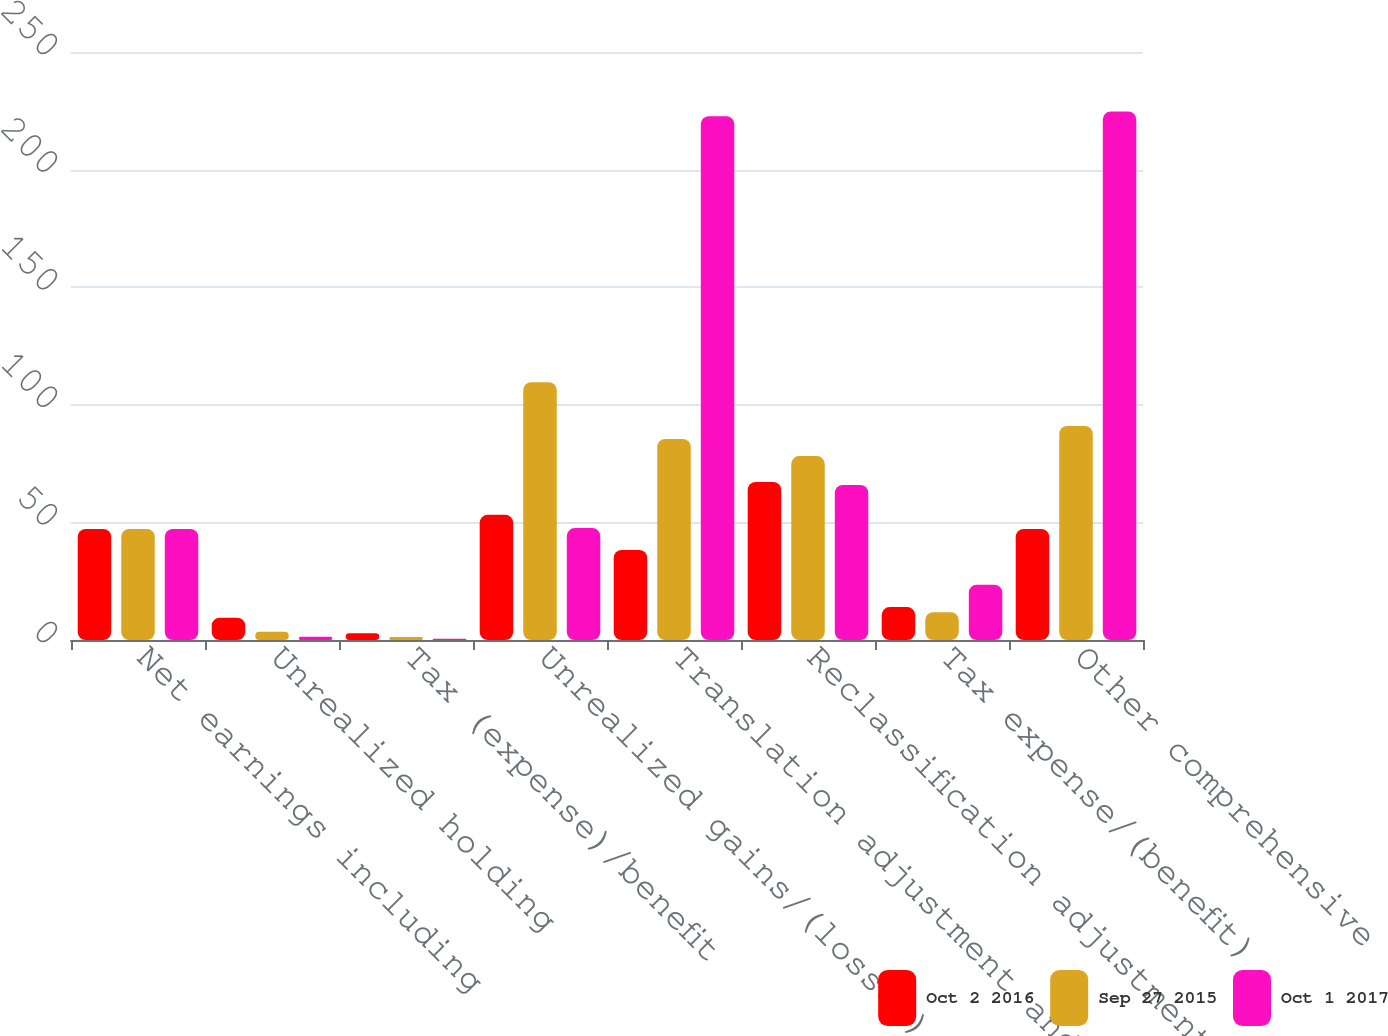Convert chart to OTSL. <chart><loc_0><loc_0><loc_500><loc_500><stacked_bar_chart><ecel><fcel>Net earnings including<fcel>Unrealized holding<fcel>Tax (expense)/benefit<fcel>Unrealized gains/(losses) on<fcel>Translation adjustment and<fcel>Reclassification adjustment<fcel>Tax expense/(benefit)<fcel>Other comprehensive<nl><fcel>Oct 2 2016<fcel>47.2<fcel>9.5<fcel>2.9<fcel>53.2<fcel>38.3<fcel>67.2<fcel>14<fcel>47.2<nl><fcel>Sep 27 2015<fcel>47.2<fcel>3.5<fcel>1.3<fcel>109.6<fcel>85.5<fcel>78.2<fcel>11.8<fcel>91<nl><fcel>Oct 1 2017<fcel>47.2<fcel>1.4<fcel>0.5<fcel>47.6<fcel>222.7<fcel>65.9<fcel>23.5<fcel>224.7<nl></chart> 